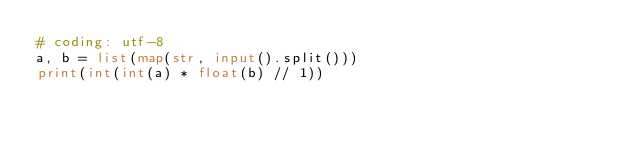Convert code to text. <code><loc_0><loc_0><loc_500><loc_500><_Python_># coding: utf-8
a, b = list(map(str, input().split()))
print(int(int(a) * float(b) // 1))</code> 